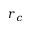<formula> <loc_0><loc_0><loc_500><loc_500>r _ { c }</formula> 